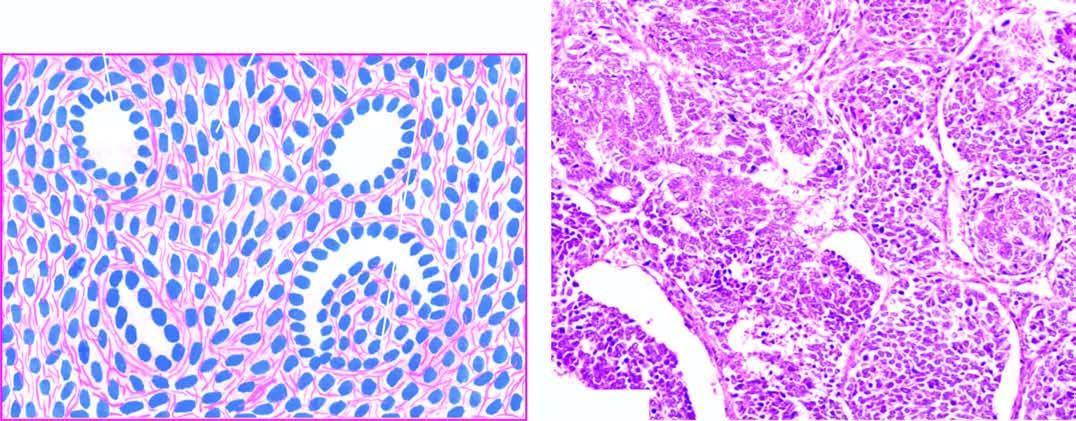what is there of small round to spindled sarcomatoid tumour cells?
Answer the question using a single word or phrase. Predominance 